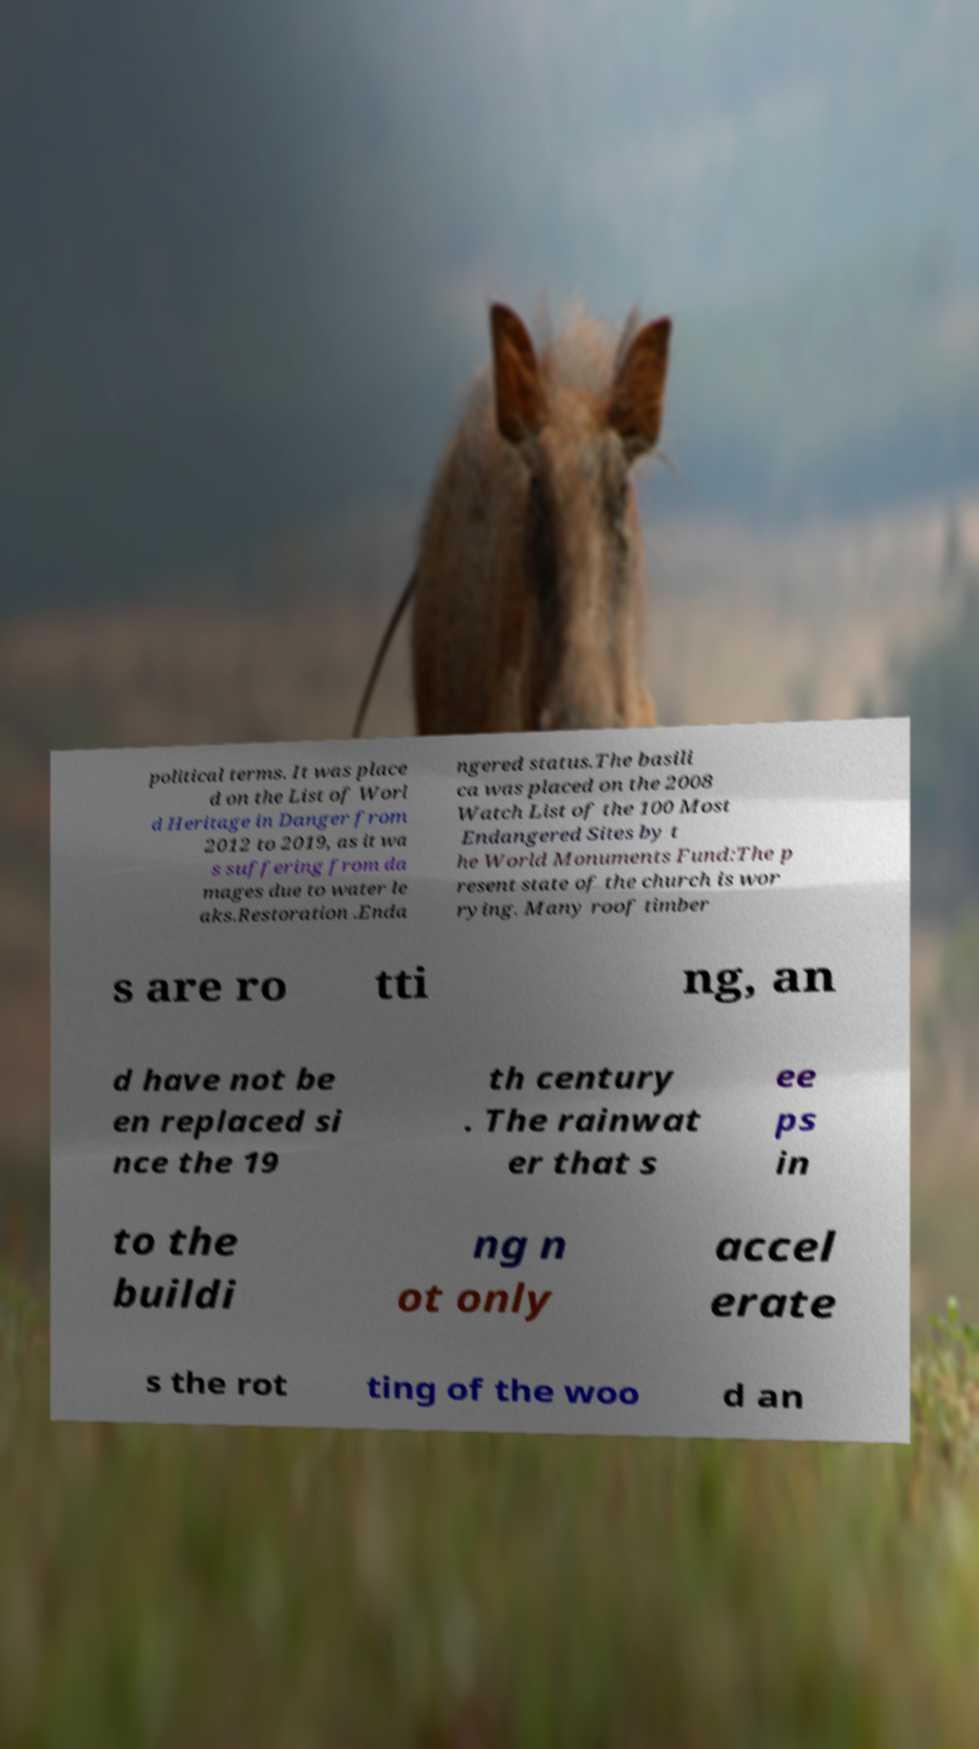I need the written content from this picture converted into text. Can you do that? political terms. It was place d on the List of Worl d Heritage in Danger from 2012 to 2019, as it wa s suffering from da mages due to water le aks.Restoration .Enda ngered status.The basili ca was placed on the 2008 Watch List of the 100 Most Endangered Sites by t he World Monuments Fund:The p resent state of the church is wor rying. Many roof timber s are ro tti ng, an d have not be en replaced si nce the 19 th century . The rainwat er that s ee ps in to the buildi ng n ot only accel erate s the rot ting of the woo d an 